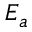<formula> <loc_0><loc_0><loc_500><loc_500>E _ { a }</formula> 